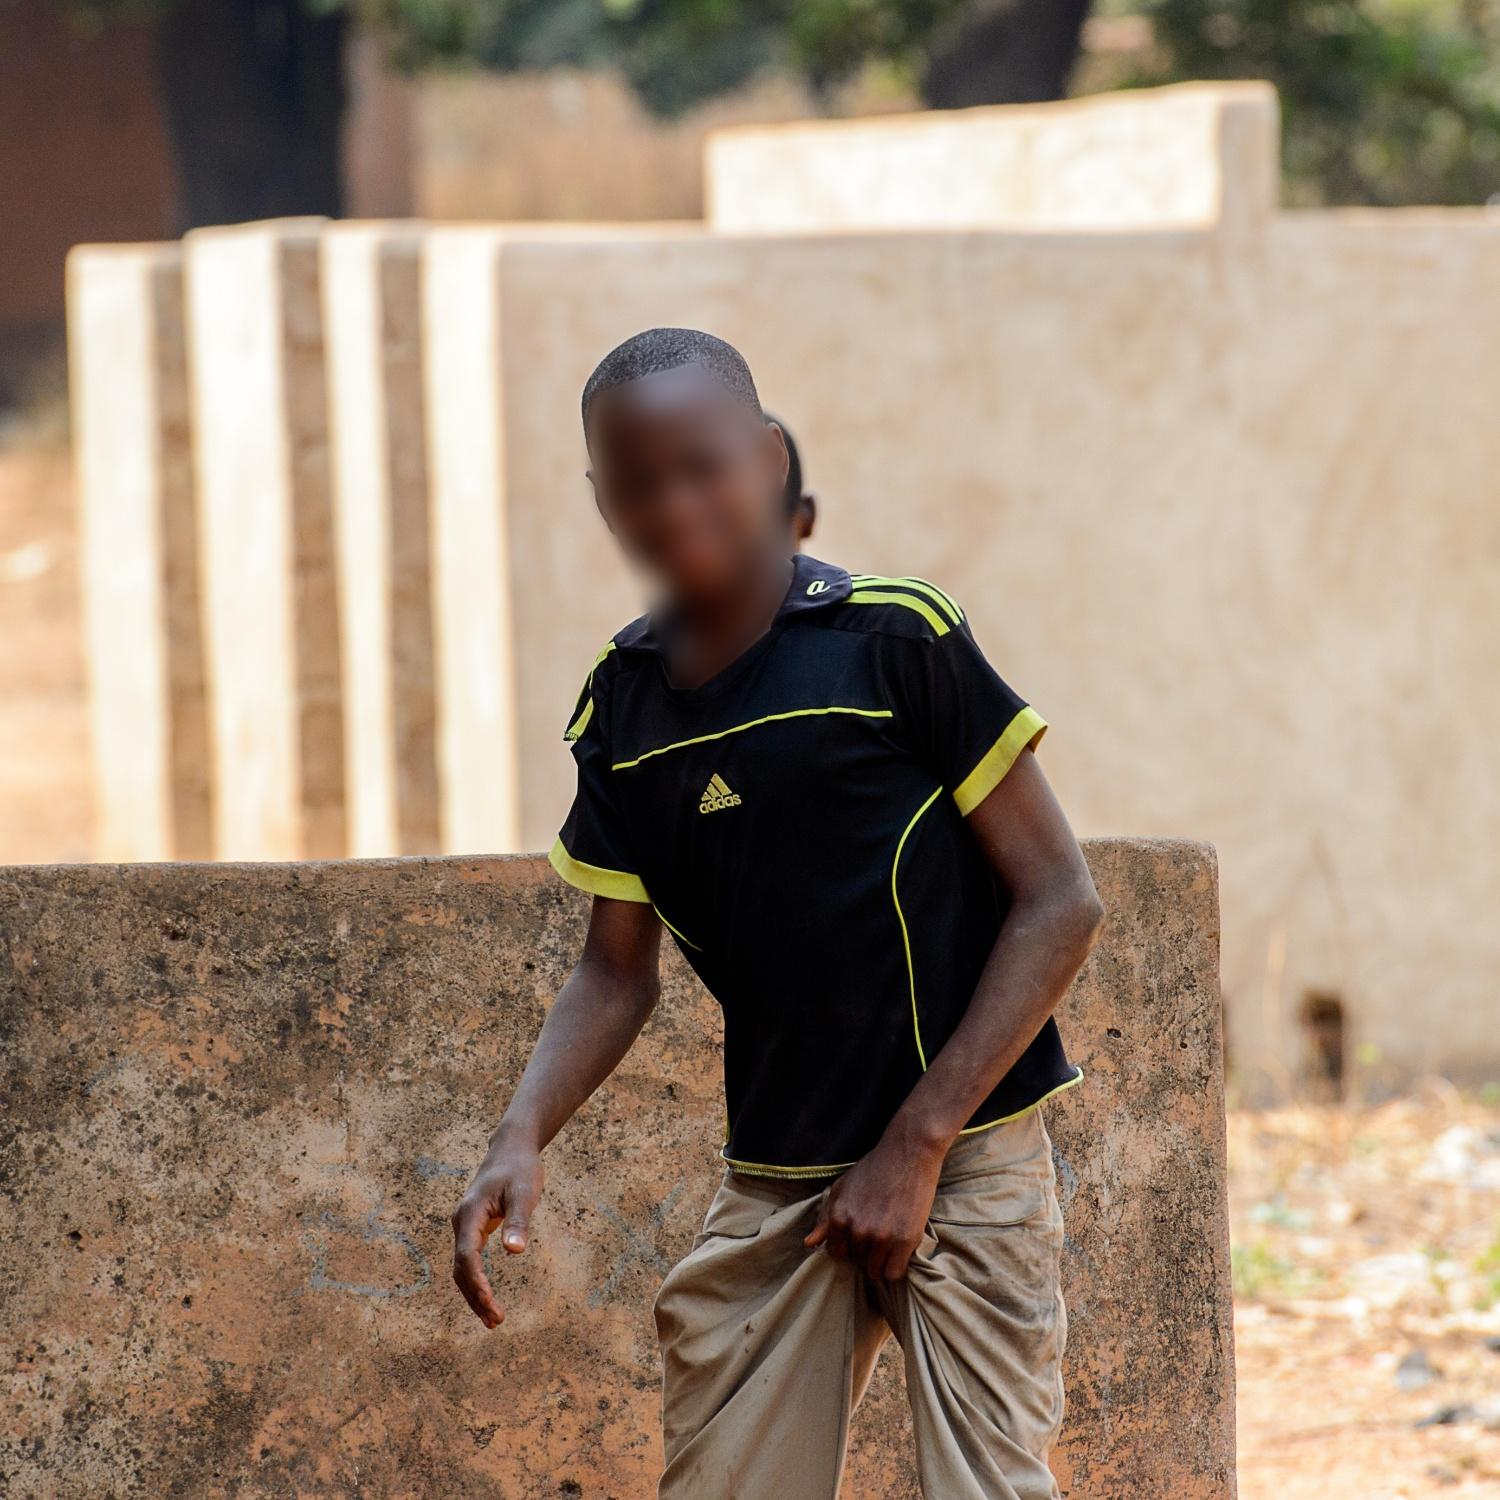Describe a plausible scenario that might be happening right now in this image. It’s a sunny afternoon, and the young boy is enjoying a leisurely moment outside. He might have just finished helping his family with daily chores and now finds solace leaning against the cool surface of the concrete wall. Nearby, another child is calling out to him, possibly inviting him to join a game or adventure. The air is filled with the sounds of nature, with occasional laughter and conversation from neighbors. The setting sun casts long shadows, adding a golden hue to the scene, as the village gradually transitions from the bustle of the day to the calm of the evening. Can you create a poetic description of the atmosphere in the image? Against the backdrop of earthen walls and stretching sky, a quiet serenity envelopes the scene. The golden sun casts gentle hues upon worn concrete, blending past and present in silent dialogue. The whisper of an afternoon breeze dances playfully against the gate, carrying with it the laughter of children, the rustling leaves, and the echo of distant conversations. In this mosaic of life and stillness, the young boy stands poised between innocence and discovery, a striking figure in his bright attire amidst the subtle earth tones. The day breathes slowly, its every sigh an invitation to linger and listen to the unspoken stories carried by the wind. 